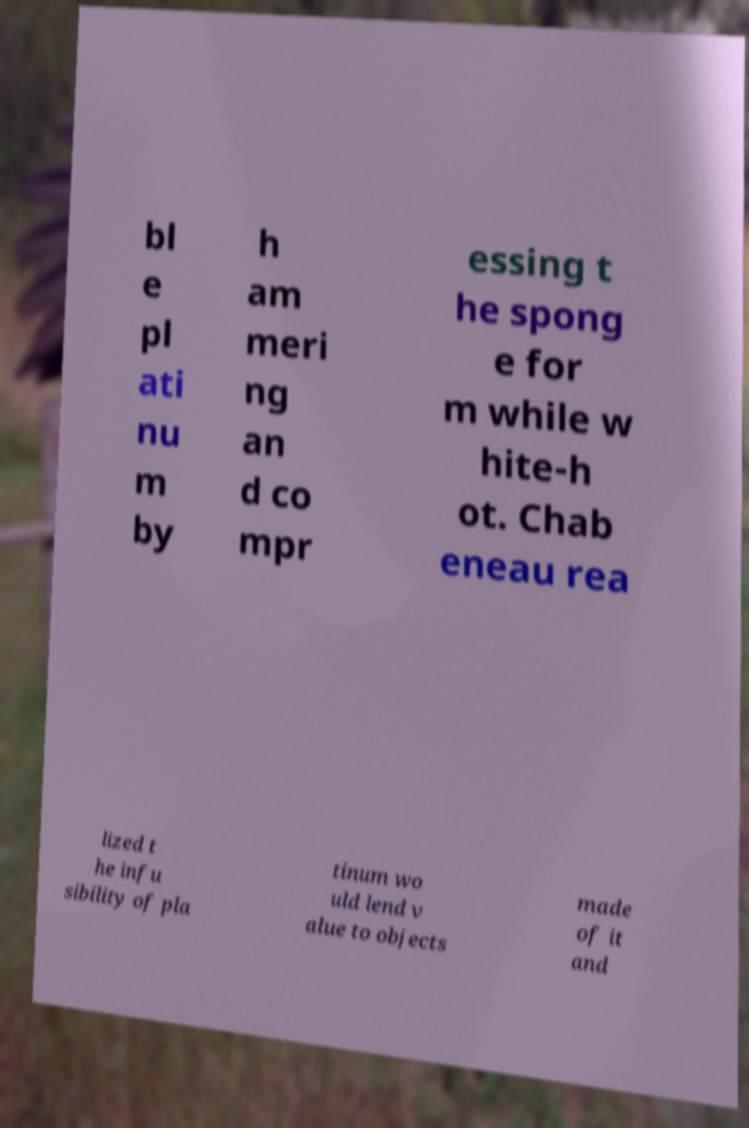Can you accurately transcribe the text from the provided image for me? bl e pl ati nu m by h am meri ng an d co mpr essing t he spong e for m while w hite-h ot. Chab eneau rea lized t he infu sibility of pla tinum wo uld lend v alue to objects made of it and 